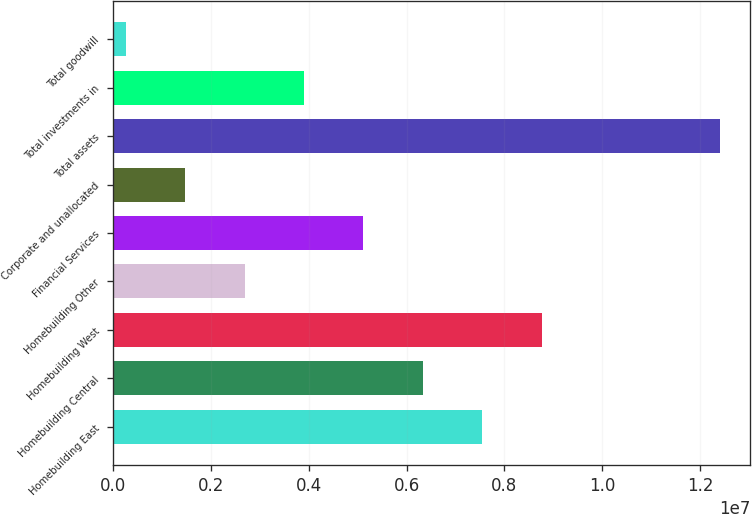<chart> <loc_0><loc_0><loc_500><loc_500><bar_chart><fcel>Homebuilding East<fcel>Homebuilding Central<fcel>Homebuilding West<fcel>Homebuilding Other<fcel>Financial Services<fcel>Corporate and unallocated<fcel>Total assets<fcel>Total investments in<fcel>Total goodwill<nl><fcel>7.5481e+06<fcel>6.33305e+06<fcel>8.76314e+06<fcel>2.68793e+06<fcel>5.11801e+06<fcel>1.47289e+06<fcel>1.24083e+07<fcel>3.90297e+06<fcel>257843<nl></chart> 